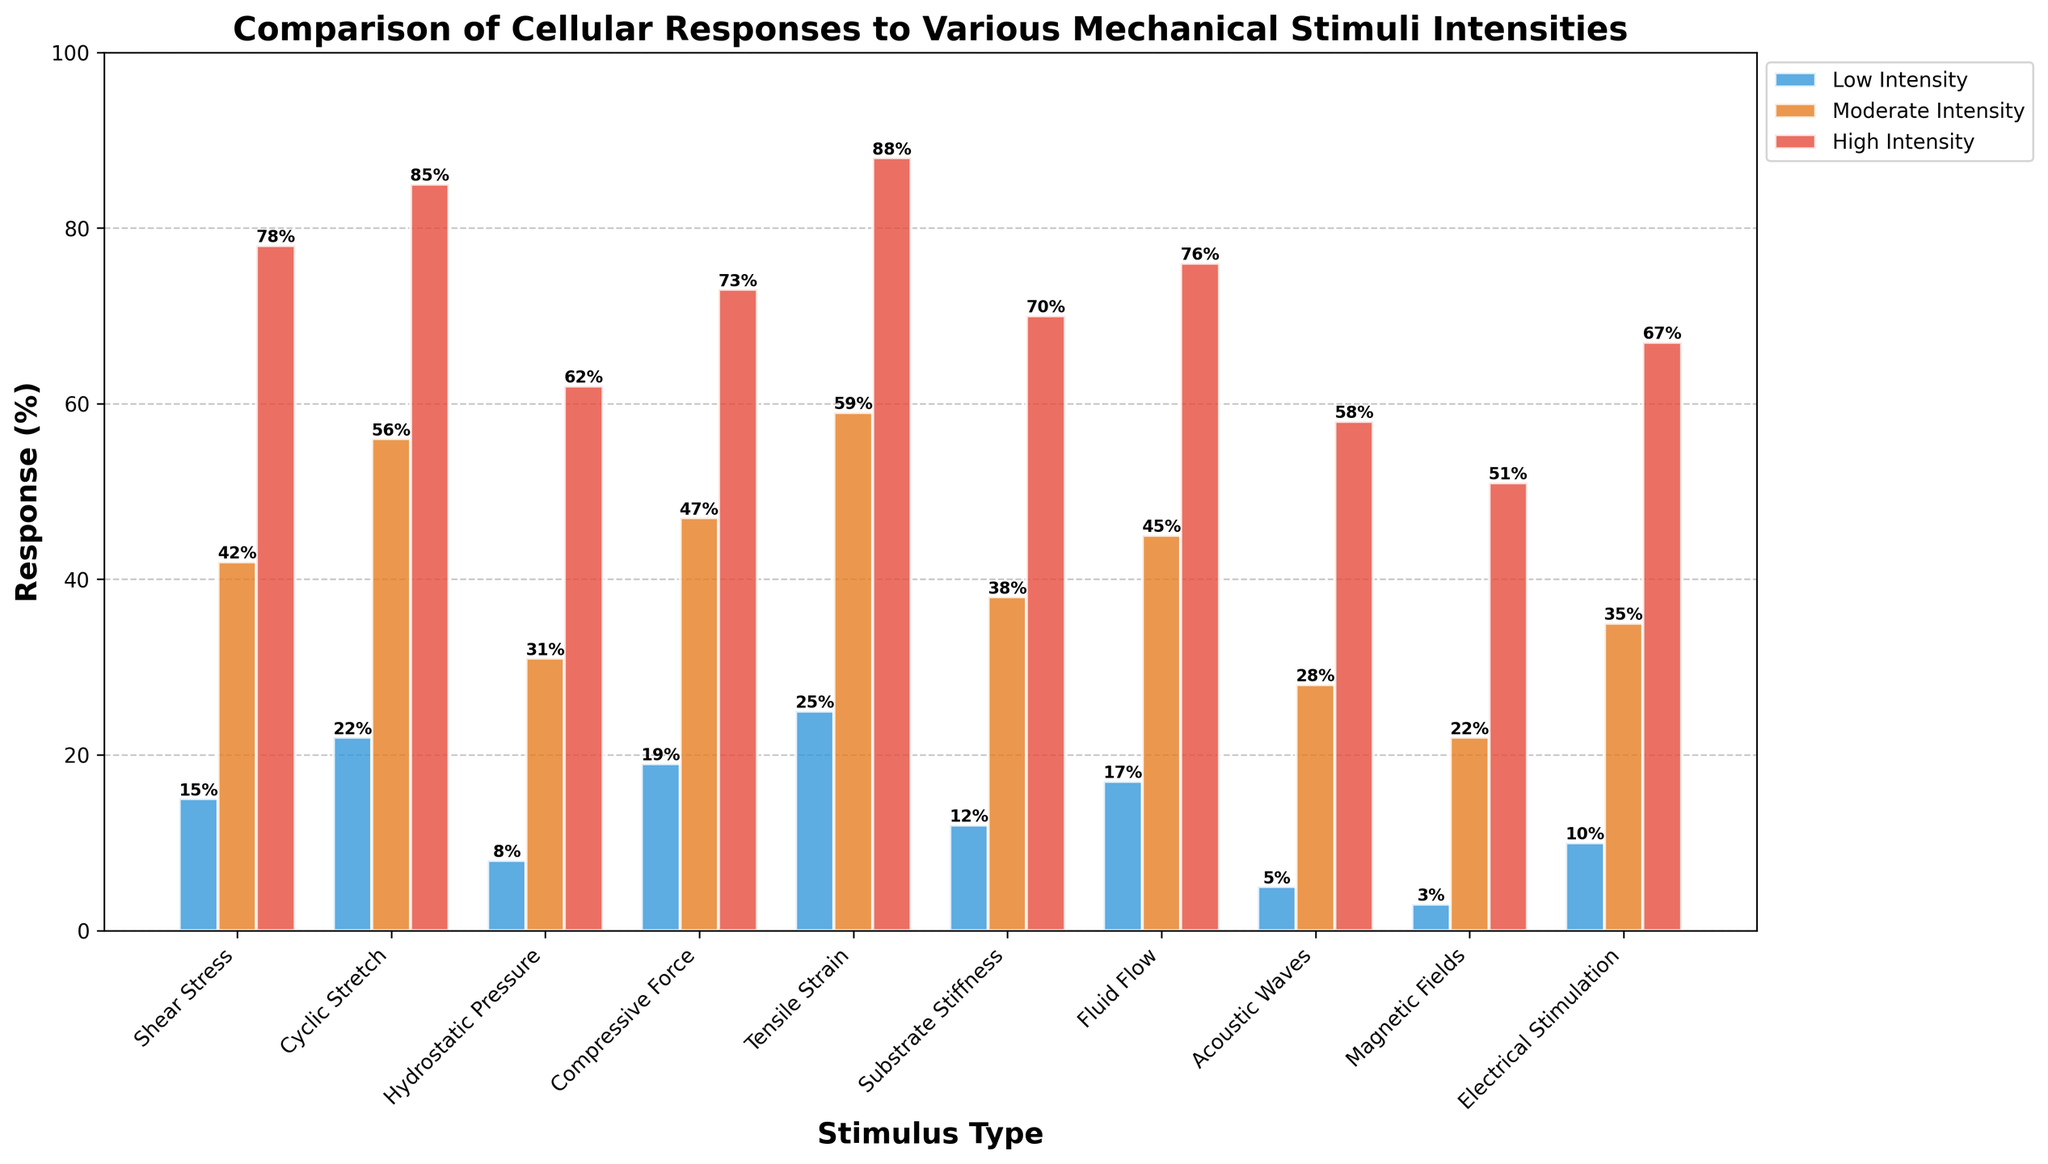Which stimulus type shows the highest cellular response at high intensity? By visually observing the bars for high intensity (red bars), Tensile Strain has the tallest bar, indicating it has the highest cellular response at high intensity.
Answer: Tensile Strain What is the average cellular response for Shear Stress across all intensity levels? Sum the cellular responses for Shear Stress at low, moderate, and high intensities (15 + 42 + 78) and divide by 3. The average is (15+42+78)/3 = 45
Answer: 45 Which stimulus type has the lowest response at low intensity? By looking at the shortest blue bars representing low intensity, Magnetic Fields has the shortest bar at low intensity.
Answer: Magnetic Fields Are there any stimulus types where the moderate intensity response is exactly twice the low intensity response? Compare the bars for each stimulus type. For Cyclic Stretch, the moderate intensity response (56) is approximately twice the low intensity response (22).
Answer: Cyclic Stretch What is the combined response for Fluid Flow at moderate and high intensities? Add the moderate and high intensity responses for Fluid Flow (45 + 76). The combined response is 45 + 76 = 121
Answer: 121 Which stimulus type shows the smallest increase in response from moderate to high intensity? Calculate the difference between high and moderate intensity responses for each stimulus. Hydrostatic Pressure shows the smallest increase (62 - 31 = 31).
Answer: Hydrostatic Pressure Compare the cellular response between Shear Stress and Compressive Force at moderate intensity. Which one is higher? By observing the moderate intensity bars (orange bars), Shear Stress has a response of 42, while Compressive Force has a response of 47. Therefore, Compressive Force is higher.
Answer: Compressive Force What is the difference in cellular response between the highest and lowest responding stimulus types at high intensity? The highest response at high intensity is Tensile Strain (88), and the lowest is Magnetic Fields (51). The difference is 88 - 51 = 37
Answer: 37 How many stimulus types have a high intensity response of 70% or more? Count the number of stimulus types where the red bar reaches 70% or more. There are 6 stimulus types: Shear Stress, Cyclic Stretch, Compressive Force, Tensile Strain, Substrate Stiffness, and Fluid Flow.
Answer: 6 What is the combined cellular response for Acoustic Waves across all intensities? Sum the cellular responses for Acoustic Waves at low, moderate, and high intensities (5 + 28 + 58). The combined response is 5 + 28 + 58 = 91
Answer: 91 